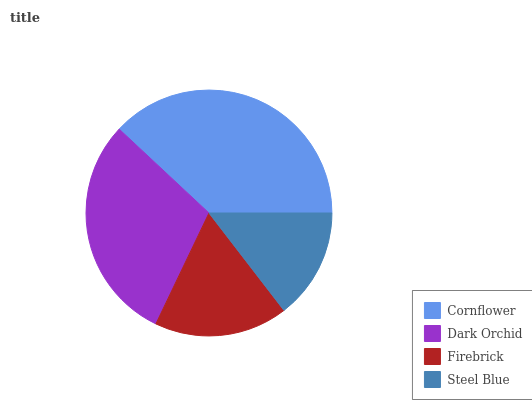Is Steel Blue the minimum?
Answer yes or no. Yes. Is Cornflower the maximum?
Answer yes or no. Yes. Is Dark Orchid the minimum?
Answer yes or no. No. Is Dark Orchid the maximum?
Answer yes or no. No. Is Cornflower greater than Dark Orchid?
Answer yes or no. Yes. Is Dark Orchid less than Cornflower?
Answer yes or no. Yes. Is Dark Orchid greater than Cornflower?
Answer yes or no. No. Is Cornflower less than Dark Orchid?
Answer yes or no. No. Is Dark Orchid the high median?
Answer yes or no. Yes. Is Firebrick the low median?
Answer yes or no. Yes. Is Firebrick the high median?
Answer yes or no. No. Is Cornflower the low median?
Answer yes or no. No. 